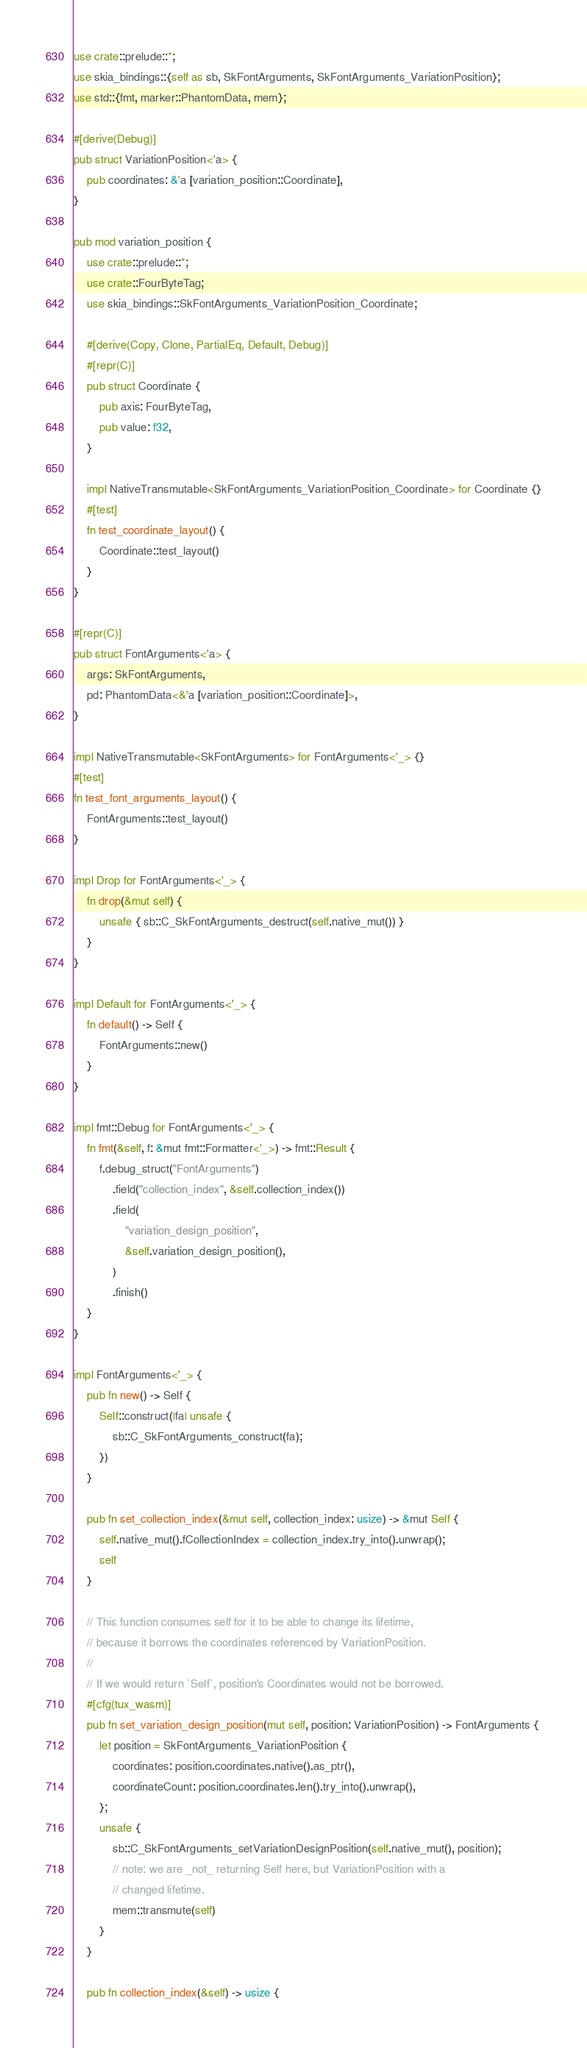<code> <loc_0><loc_0><loc_500><loc_500><_Rust_>use crate::prelude::*;
use skia_bindings::{self as sb, SkFontArguments, SkFontArguments_VariationPosition};
use std::{fmt, marker::PhantomData, mem};

#[derive(Debug)]
pub struct VariationPosition<'a> {
    pub coordinates: &'a [variation_position::Coordinate],
}

pub mod variation_position {
    use crate::prelude::*;
    use crate::FourByteTag;
    use skia_bindings::SkFontArguments_VariationPosition_Coordinate;

    #[derive(Copy, Clone, PartialEq, Default, Debug)]
    #[repr(C)]
    pub struct Coordinate {
        pub axis: FourByteTag,
        pub value: f32,
    }

    impl NativeTransmutable<SkFontArguments_VariationPosition_Coordinate> for Coordinate {}
    #[test]
    fn test_coordinate_layout() {
        Coordinate::test_layout()
    }
}

#[repr(C)]
pub struct FontArguments<'a> {
    args: SkFontArguments,
    pd: PhantomData<&'a [variation_position::Coordinate]>,
}

impl NativeTransmutable<SkFontArguments> for FontArguments<'_> {}
#[test]
fn test_font_arguments_layout() {
    FontArguments::test_layout()
}

impl Drop for FontArguments<'_> {
    fn drop(&mut self) {
        unsafe { sb::C_SkFontArguments_destruct(self.native_mut()) }
    }
}

impl Default for FontArguments<'_> {
    fn default() -> Self {
        FontArguments::new()
    }
}

impl fmt::Debug for FontArguments<'_> {
    fn fmt(&self, f: &mut fmt::Formatter<'_>) -> fmt::Result {
        f.debug_struct("FontArguments")
            .field("collection_index", &self.collection_index())
            .field(
                "variation_design_position",
                &self.variation_design_position(),
            )
            .finish()
    }
}

impl FontArguments<'_> {
    pub fn new() -> Self {
        Self::construct(|fa| unsafe {
            sb::C_SkFontArguments_construct(fa);
        })
    }

    pub fn set_collection_index(&mut self, collection_index: usize) -> &mut Self {
        self.native_mut().fCollectionIndex = collection_index.try_into().unwrap();
        self
    }

    // This function consumes self for it to be able to change its lifetime,
    // because it borrows the coordinates referenced by VariationPosition.
    //
    // If we would return `Self`, position's Coordinates would not be borrowed.
    #[cfg(tux_wasm)]
    pub fn set_variation_design_position(mut self, position: VariationPosition) -> FontArguments {
        let position = SkFontArguments_VariationPosition {
            coordinates: position.coordinates.native().as_ptr(),
            coordinateCount: position.coordinates.len().try_into().unwrap(),
        };
        unsafe {
            sb::C_SkFontArguments_setVariationDesignPosition(self.native_mut(), position);
            // note: we are _not_ returning Self here, but VariationPosition with a
            // changed lifetime.
            mem::transmute(self)
        }
    }

    pub fn collection_index(&self) -> usize {</code> 